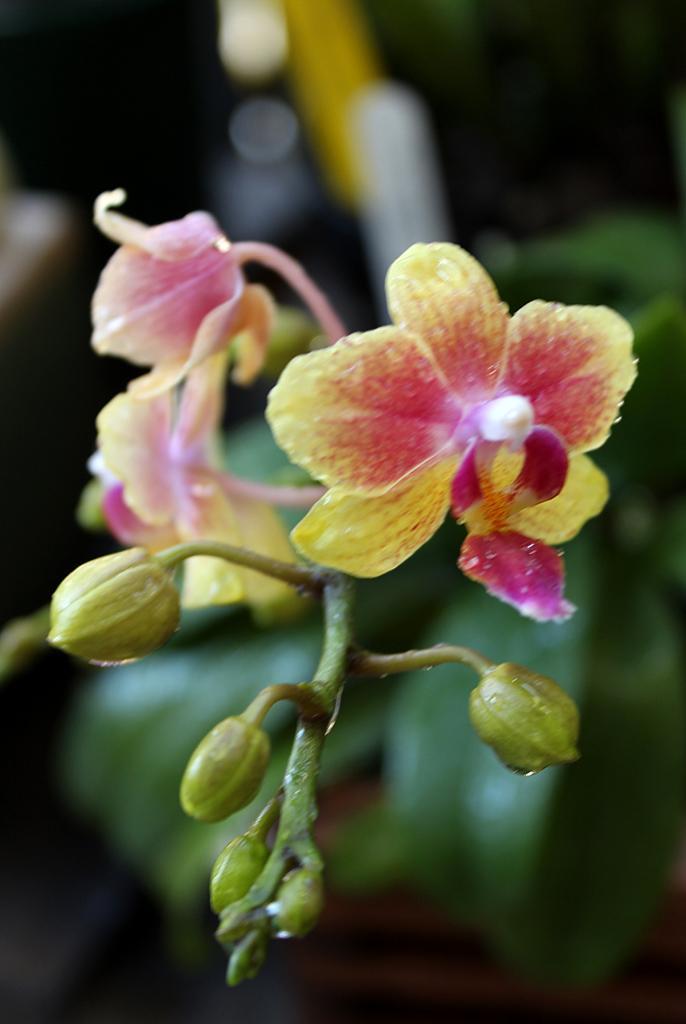Please provide a concise description of this image. In this image I can see the flowers and buds to the plants. I can see these flowers are in yellow and pink color. And there is a blurred background. 